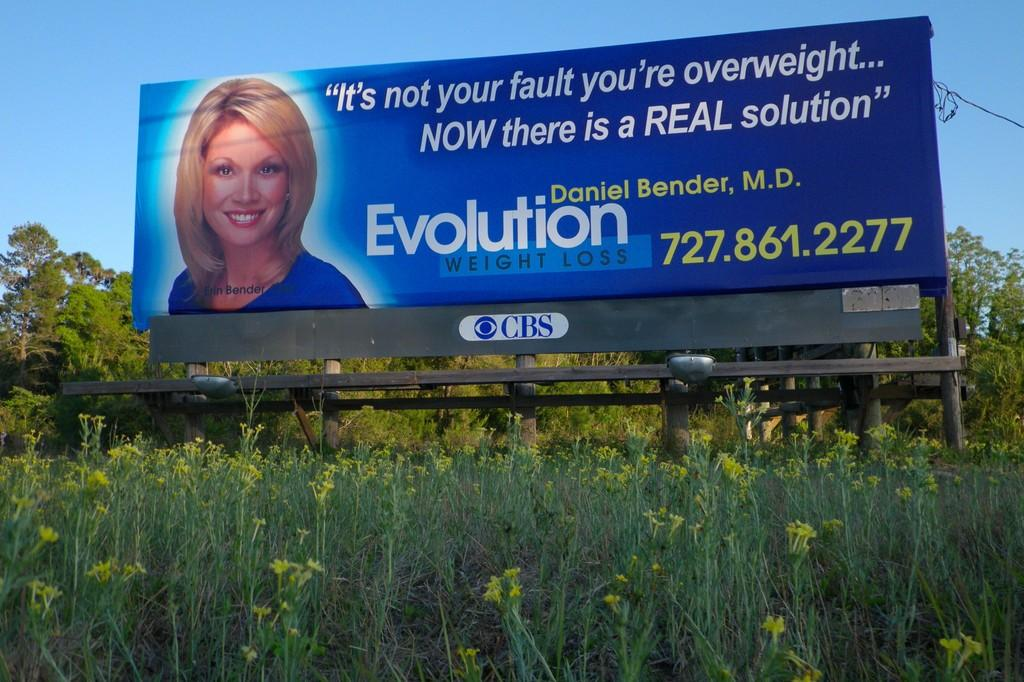<image>
Share a concise interpretation of the image provided. a billboard from cbs about doctor daniel bender 